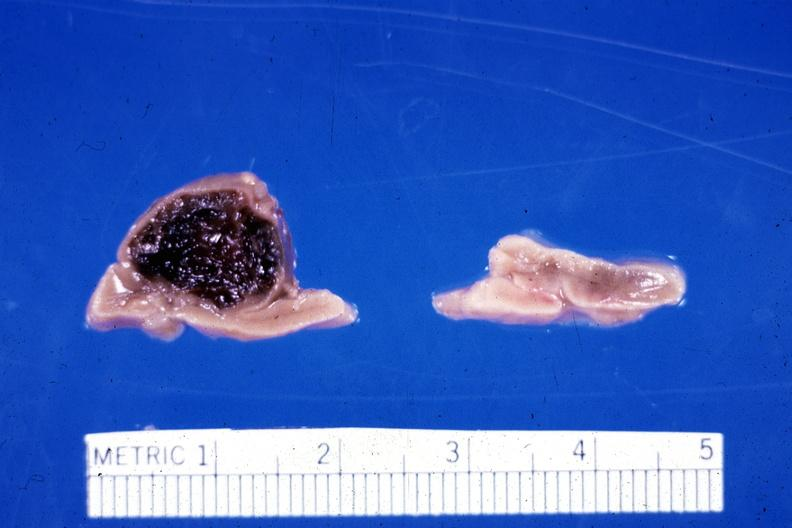what had ruptured causing 20 ml hemoperitoneum unusual lesion?
Answer the question using a single word or phrase. Fixed tissue hemorrhage hematoma in left adrenal of premature 30 week gestation gram infant 